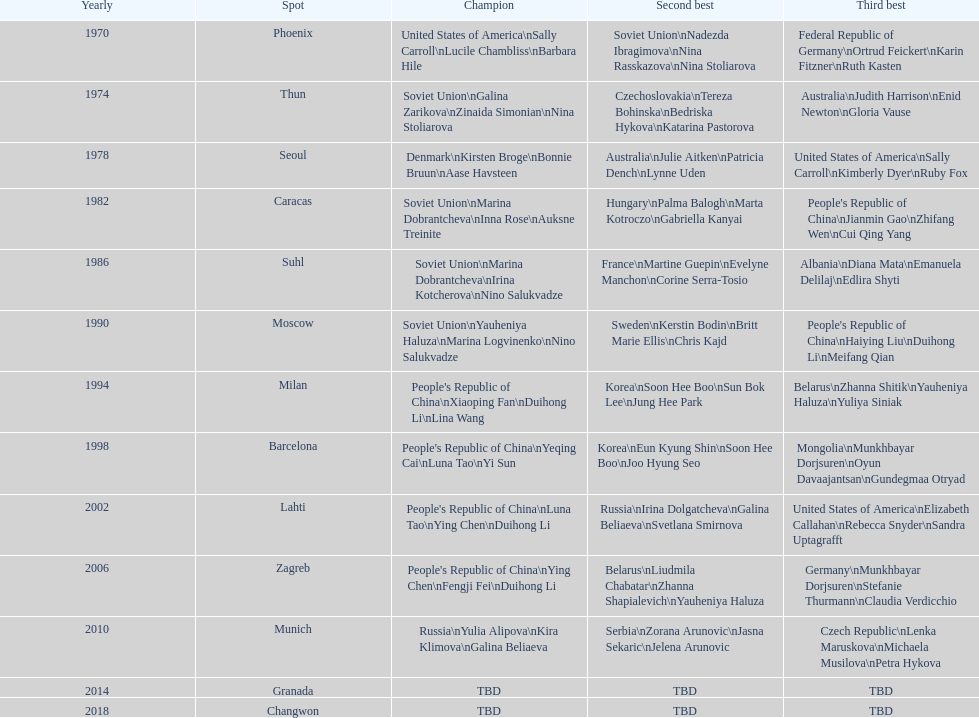What is the number of total bronze medals that germany has won? 1. 